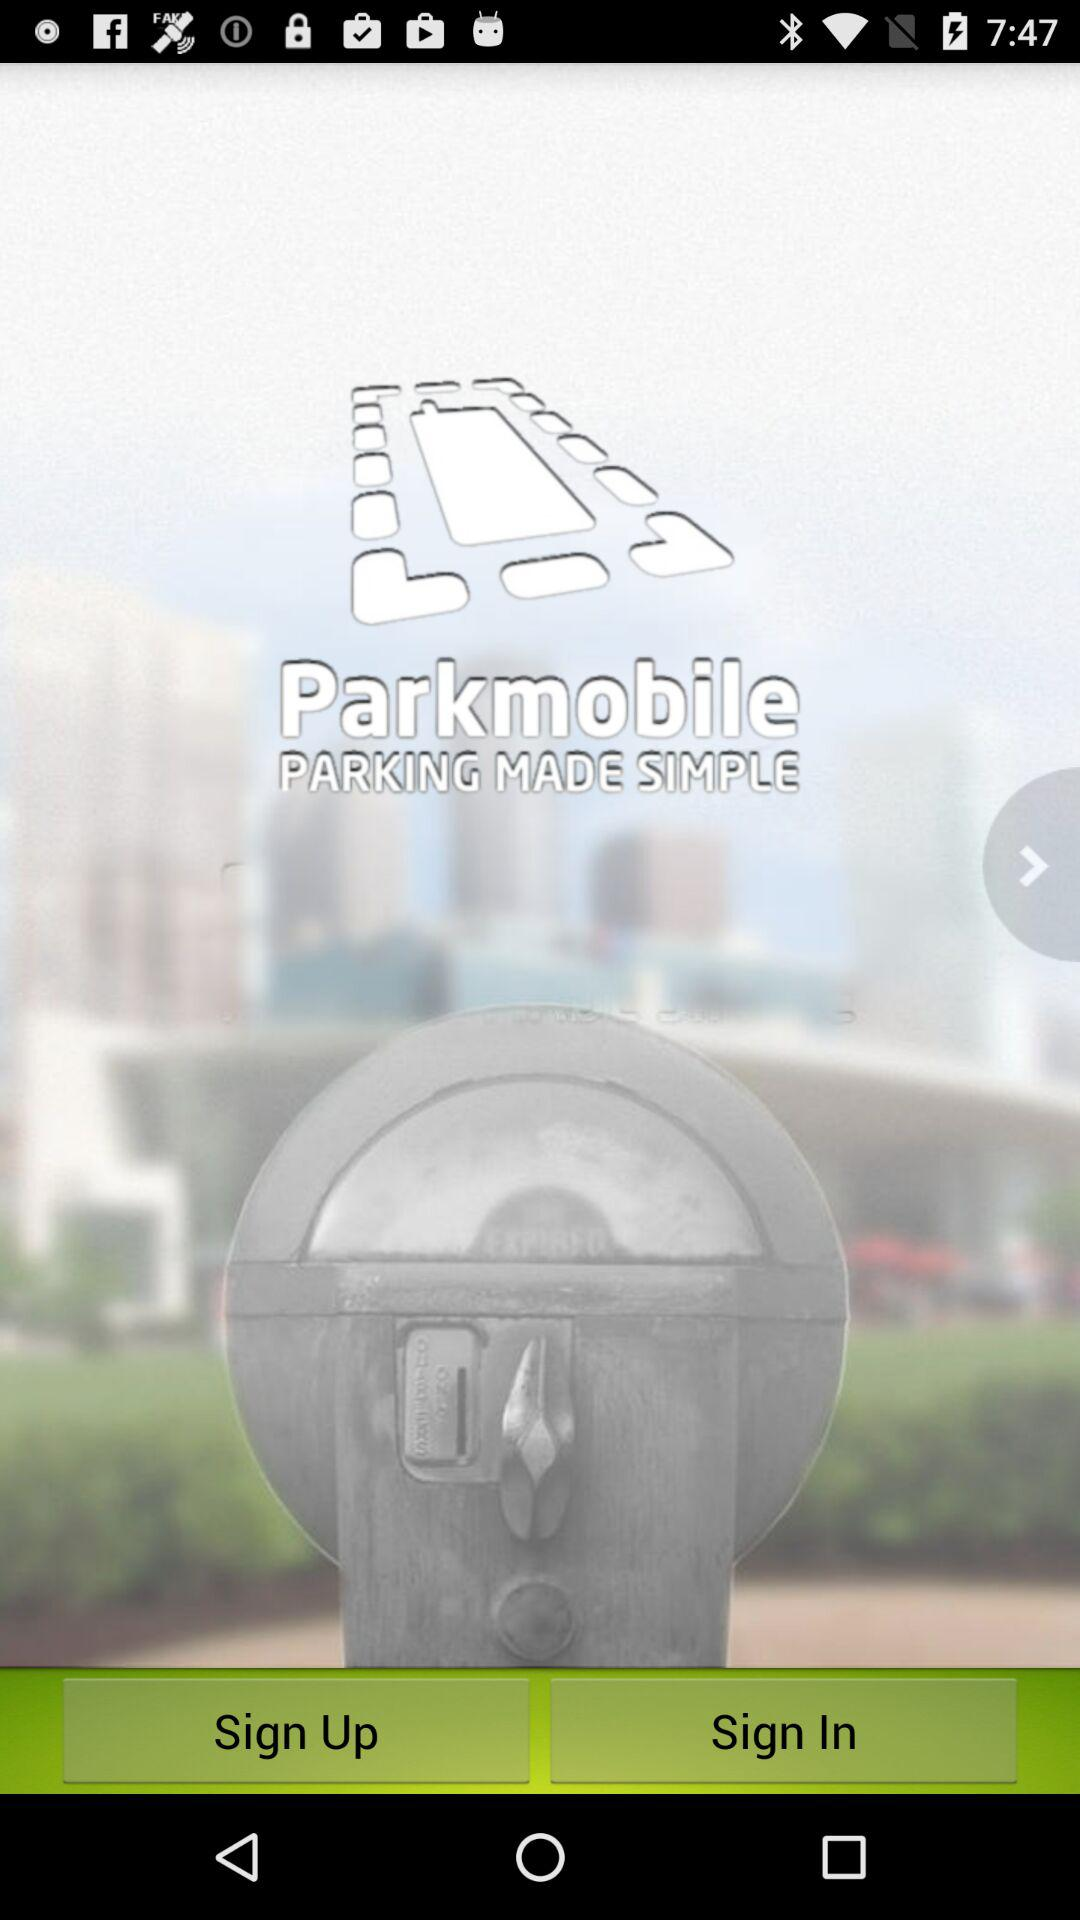What are options to Log in the Application?
When the provided information is insufficient, respond with <no answer>. <no answer> 